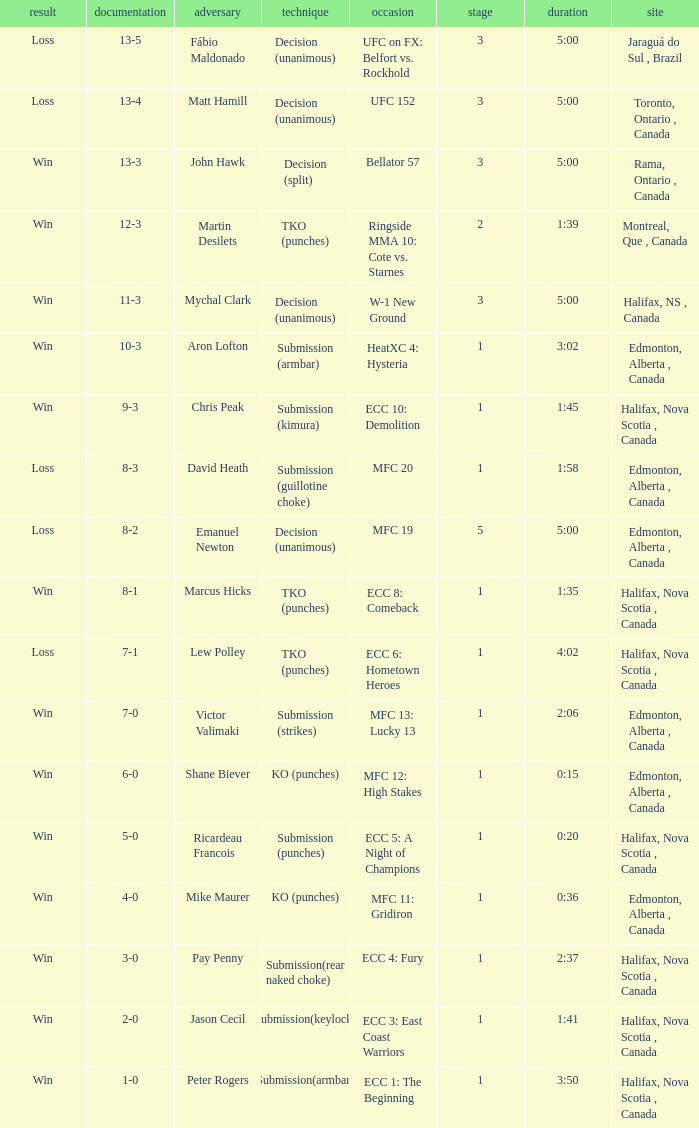What is the location of the match with an event of ecc 8: comeback? Halifax, Nova Scotia , Canada. 